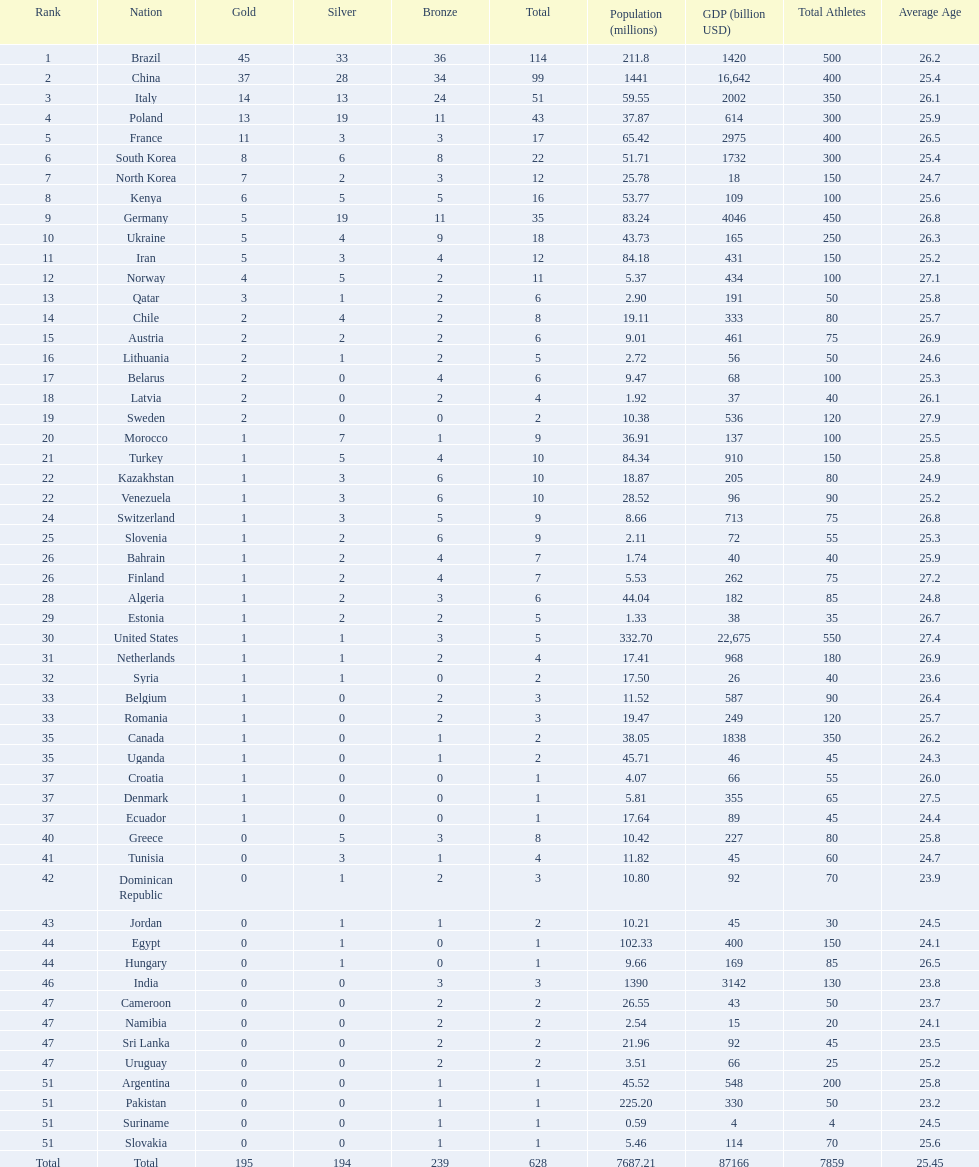How many total medals did norway win? 11. 